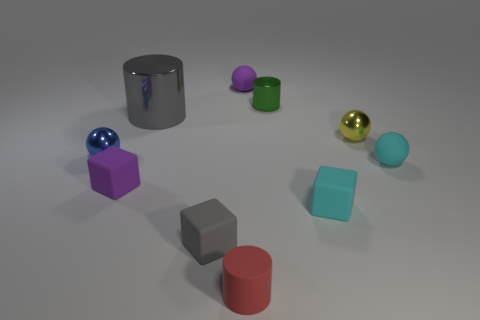How big is the block right of the object that is behind the small green metal thing?
Provide a short and direct response. Small. Is there a red rubber ball of the same size as the green object?
Provide a succinct answer. No. There is another large cylinder that is the same material as the green cylinder; what color is it?
Your answer should be compact. Gray. Are there fewer blue metal spheres than gray objects?
Your response must be concise. Yes. There is a ball that is in front of the tiny yellow thing and on the right side of the blue metallic sphere; what is its material?
Make the answer very short. Rubber. There is a metallic sphere to the right of the small purple sphere; is there a small yellow object in front of it?
Provide a succinct answer. No. What number of blocks are the same color as the big object?
Your answer should be compact. 1. Are the small yellow ball and the purple cube made of the same material?
Provide a short and direct response. No. There is a big gray metallic object; are there any red cylinders in front of it?
Your response must be concise. Yes. The small purple cube that is to the left of the cylinder in front of the gray matte object is made of what material?
Offer a terse response. Rubber. 